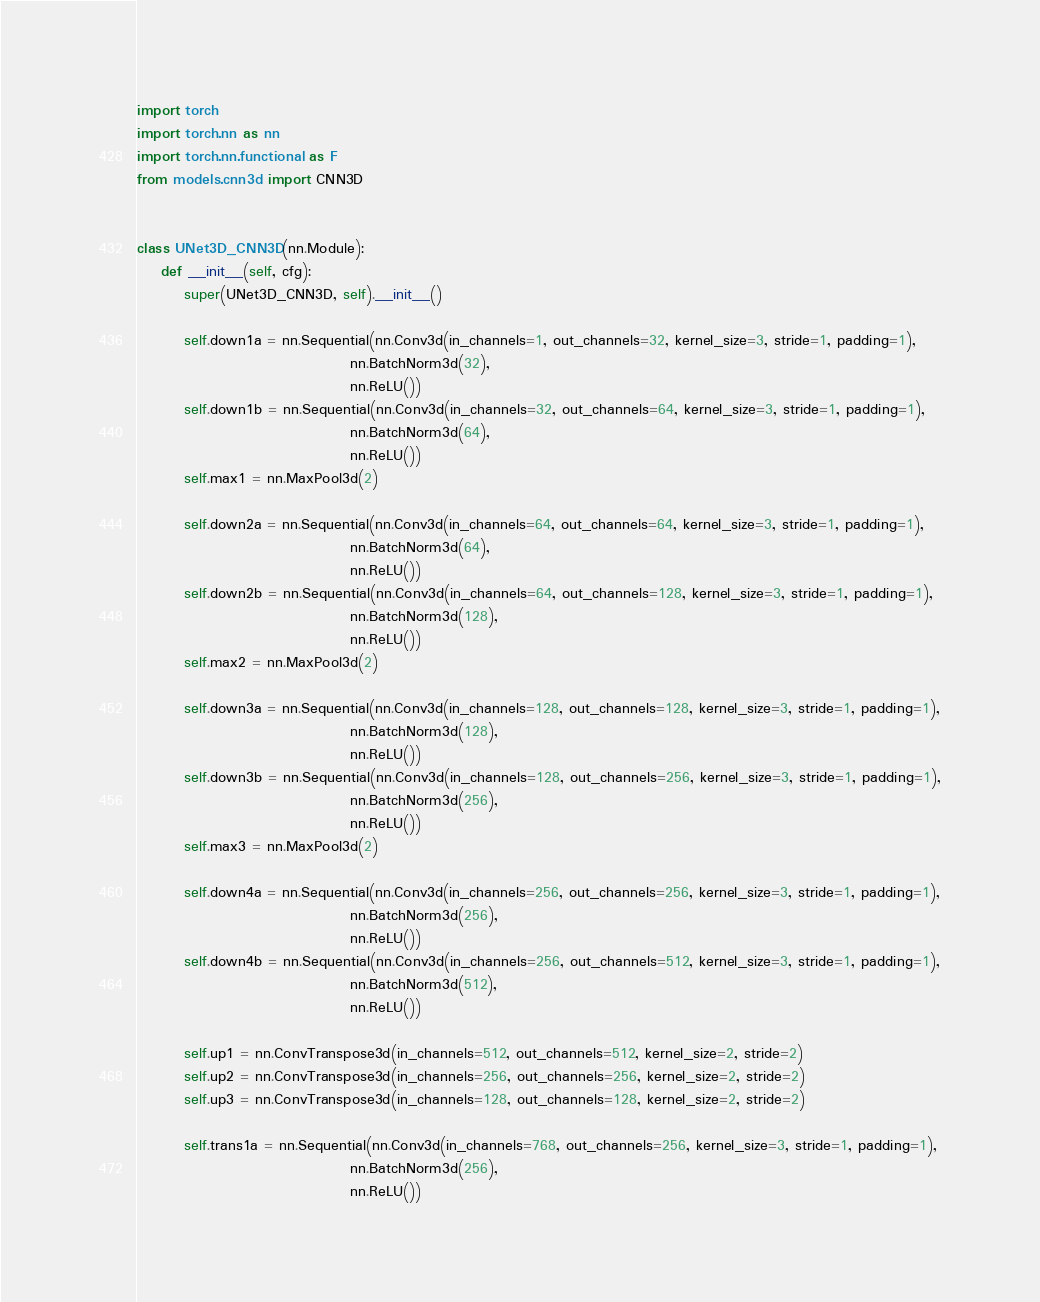Convert code to text. <code><loc_0><loc_0><loc_500><loc_500><_Python_>import torch
import torch.nn as nn
import torch.nn.functional as F
from models.cnn3d import CNN3D


class UNet3D_CNN3D(nn.Module):
    def __init__(self, cfg):
        super(UNet3D_CNN3D, self).__init__()

        self.down1a = nn.Sequential(nn.Conv3d(in_channels=1, out_channels=32, kernel_size=3, stride=1, padding=1),
                                    nn.BatchNorm3d(32),
                                    nn.ReLU())
        self.down1b = nn.Sequential(nn.Conv3d(in_channels=32, out_channels=64, kernel_size=3, stride=1, padding=1),
                                    nn.BatchNorm3d(64),
                                    nn.ReLU())
        self.max1 = nn.MaxPool3d(2)

        self.down2a = nn.Sequential(nn.Conv3d(in_channels=64, out_channels=64, kernel_size=3, stride=1, padding=1),
                                    nn.BatchNorm3d(64),
                                    nn.ReLU())
        self.down2b = nn.Sequential(nn.Conv3d(in_channels=64, out_channels=128, kernel_size=3, stride=1, padding=1),
                                    nn.BatchNorm3d(128),
                                    nn.ReLU())
        self.max2 = nn.MaxPool3d(2)

        self.down3a = nn.Sequential(nn.Conv3d(in_channels=128, out_channels=128, kernel_size=3, stride=1, padding=1),
                                    nn.BatchNorm3d(128),
                                    nn.ReLU())
        self.down3b = nn.Sequential(nn.Conv3d(in_channels=128, out_channels=256, kernel_size=3, stride=1, padding=1),
                                    nn.BatchNorm3d(256),
                                    nn.ReLU())
        self.max3 = nn.MaxPool3d(2)

        self.down4a = nn.Sequential(nn.Conv3d(in_channels=256, out_channels=256, kernel_size=3, stride=1, padding=1),
                                    nn.BatchNorm3d(256),
                                    nn.ReLU())
        self.down4b = nn.Sequential(nn.Conv3d(in_channels=256, out_channels=512, kernel_size=3, stride=1, padding=1),
                                    nn.BatchNorm3d(512),
                                    nn.ReLU())

        self.up1 = nn.ConvTranspose3d(in_channels=512, out_channels=512, kernel_size=2, stride=2)
        self.up2 = nn.ConvTranspose3d(in_channels=256, out_channels=256, kernel_size=2, stride=2)
        self.up3 = nn.ConvTranspose3d(in_channels=128, out_channels=128, kernel_size=2, stride=2)

        self.trans1a = nn.Sequential(nn.Conv3d(in_channels=768, out_channels=256, kernel_size=3, stride=1, padding=1),
                                    nn.BatchNorm3d(256),
                                    nn.ReLU())</code> 